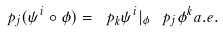<formula> <loc_0><loc_0><loc_500><loc_500>\ p _ { j } ( \psi ^ { i } \circ \phi ) = \ p _ { k } \psi ^ { i } | _ { \phi } \, \ p _ { j } \phi ^ { k } a . e .</formula> 